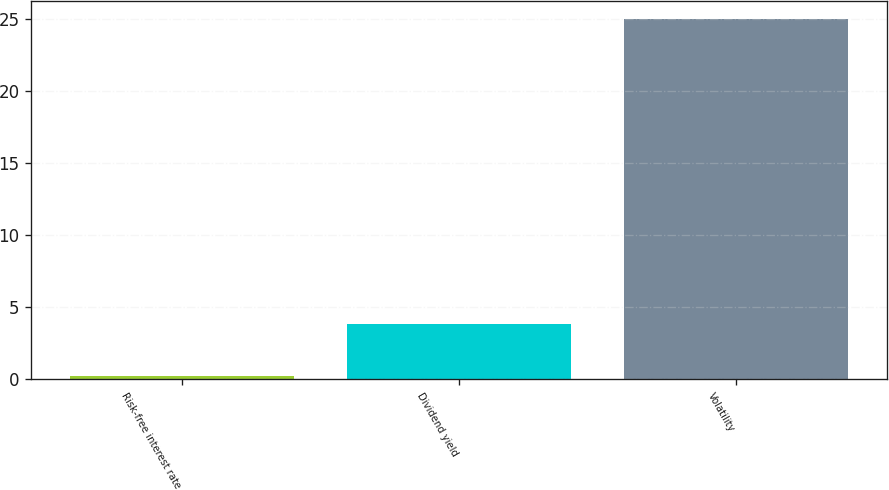Convert chart. <chart><loc_0><loc_0><loc_500><loc_500><bar_chart><fcel>Risk-free interest rate<fcel>Dividend yield<fcel>Volatility<nl><fcel>0.2<fcel>3.8<fcel>25<nl></chart> 